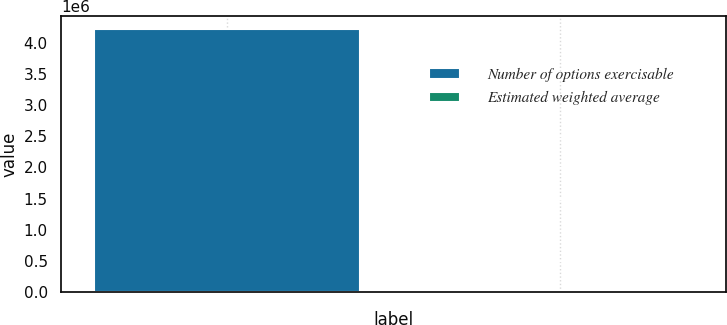Convert chart. <chart><loc_0><loc_0><loc_500><loc_500><bar_chart><fcel>Number of options exercisable<fcel>Estimated weighted average<nl><fcel>4.21956e+06<fcel>15.55<nl></chart> 